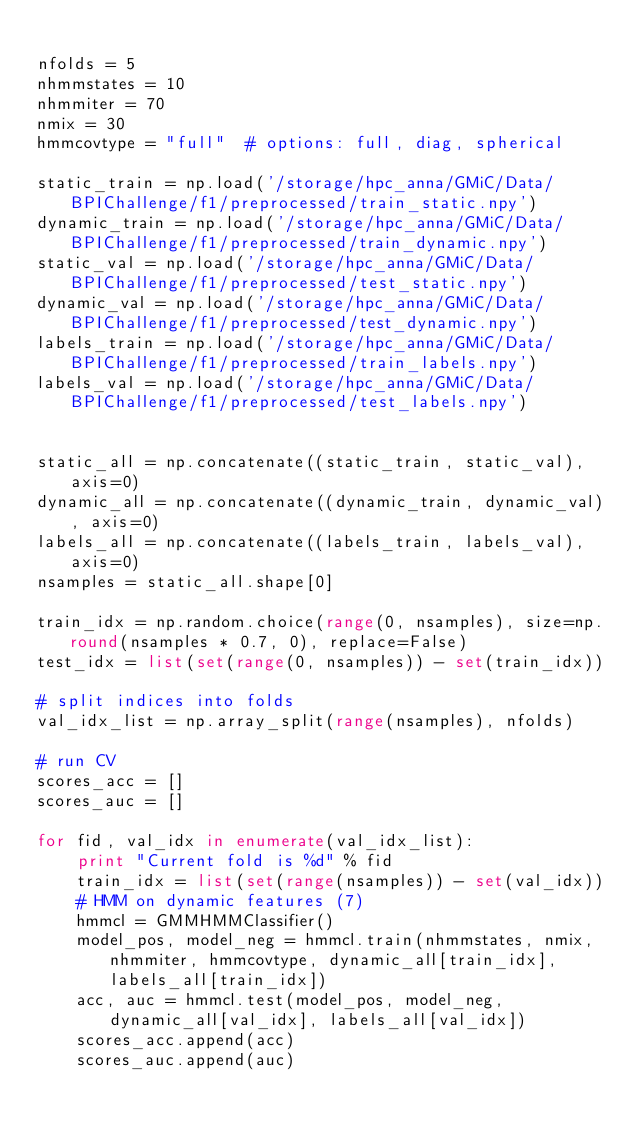Convert code to text. <code><loc_0><loc_0><loc_500><loc_500><_Python_>
nfolds = 5
nhmmstates = 10
nhmmiter = 70
nmix = 30
hmmcovtype = "full"  # options: full, diag, spherical

static_train = np.load('/storage/hpc_anna/GMiC/Data/BPIChallenge/f1/preprocessed/train_static.npy')
dynamic_train = np.load('/storage/hpc_anna/GMiC/Data/BPIChallenge/f1/preprocessed/train_dynamic.npy')
static_val = np.load('/storage/hpc_anna/GMiC/Data/BPIChallenge/f1/preprocessed/test_static.npy')
dynamic_val = np.load('/storage/hpc_anna/GMiC/Data/BPIChallenge/f1/preprocessed/test_dynamic.npy')
labels_train = np.load('/storage/hpc_anna/GMiC/Data/BPIChallenge/f1/preprocessed/train_labels.npy')
labels_val = np.load('/storage/hpc_anna/GMiC/Data/BPIChallenge/f1/preprocessed/test_labels.npy')


static_all = np.concatenate((static_train, static_val), axis=0)
dynamic_all = np.concatenate((dynamic_train, dynamic_val), axis=0)
labels_all = np.concatenate((labels_train, labels_val), axis=0)
nsamples = static_all.shape[0]

train_idx = np.random.choice(range(0, nsamples), size=np.round(nsamples * 0.7, 0), replace=False)
test_idx = list(set(range(0, nsamples)) - set(train_idx))

# split indices into folds
val_idx_list = np.array_split(range(nsamples), nfolds)

# run CV
scores_acc = []
scores_auc = []

for fid, val_idx in enumerate(val_idx_list):
    print "Current fold is %d" % fid
    train_idx = list(set(range(nsamples)) - set(val_idx))
    # HMM on dynamic features (7)
    hmmcl = GMMHMMClassifier()
    model_pos, model_neg = hmmcl.train(nhmmstates, nmix, nhmmiter, hmmcovtype, dynamic_all[train_idx], labels_all[train_idx])
    acc, auc = hmmcl.test(model_pos, model_neg, dynamic_all[val_idx], labels_all[val_idx])
    scores_acc.append(acc)
    scores_auc.append(auc)
</code> 